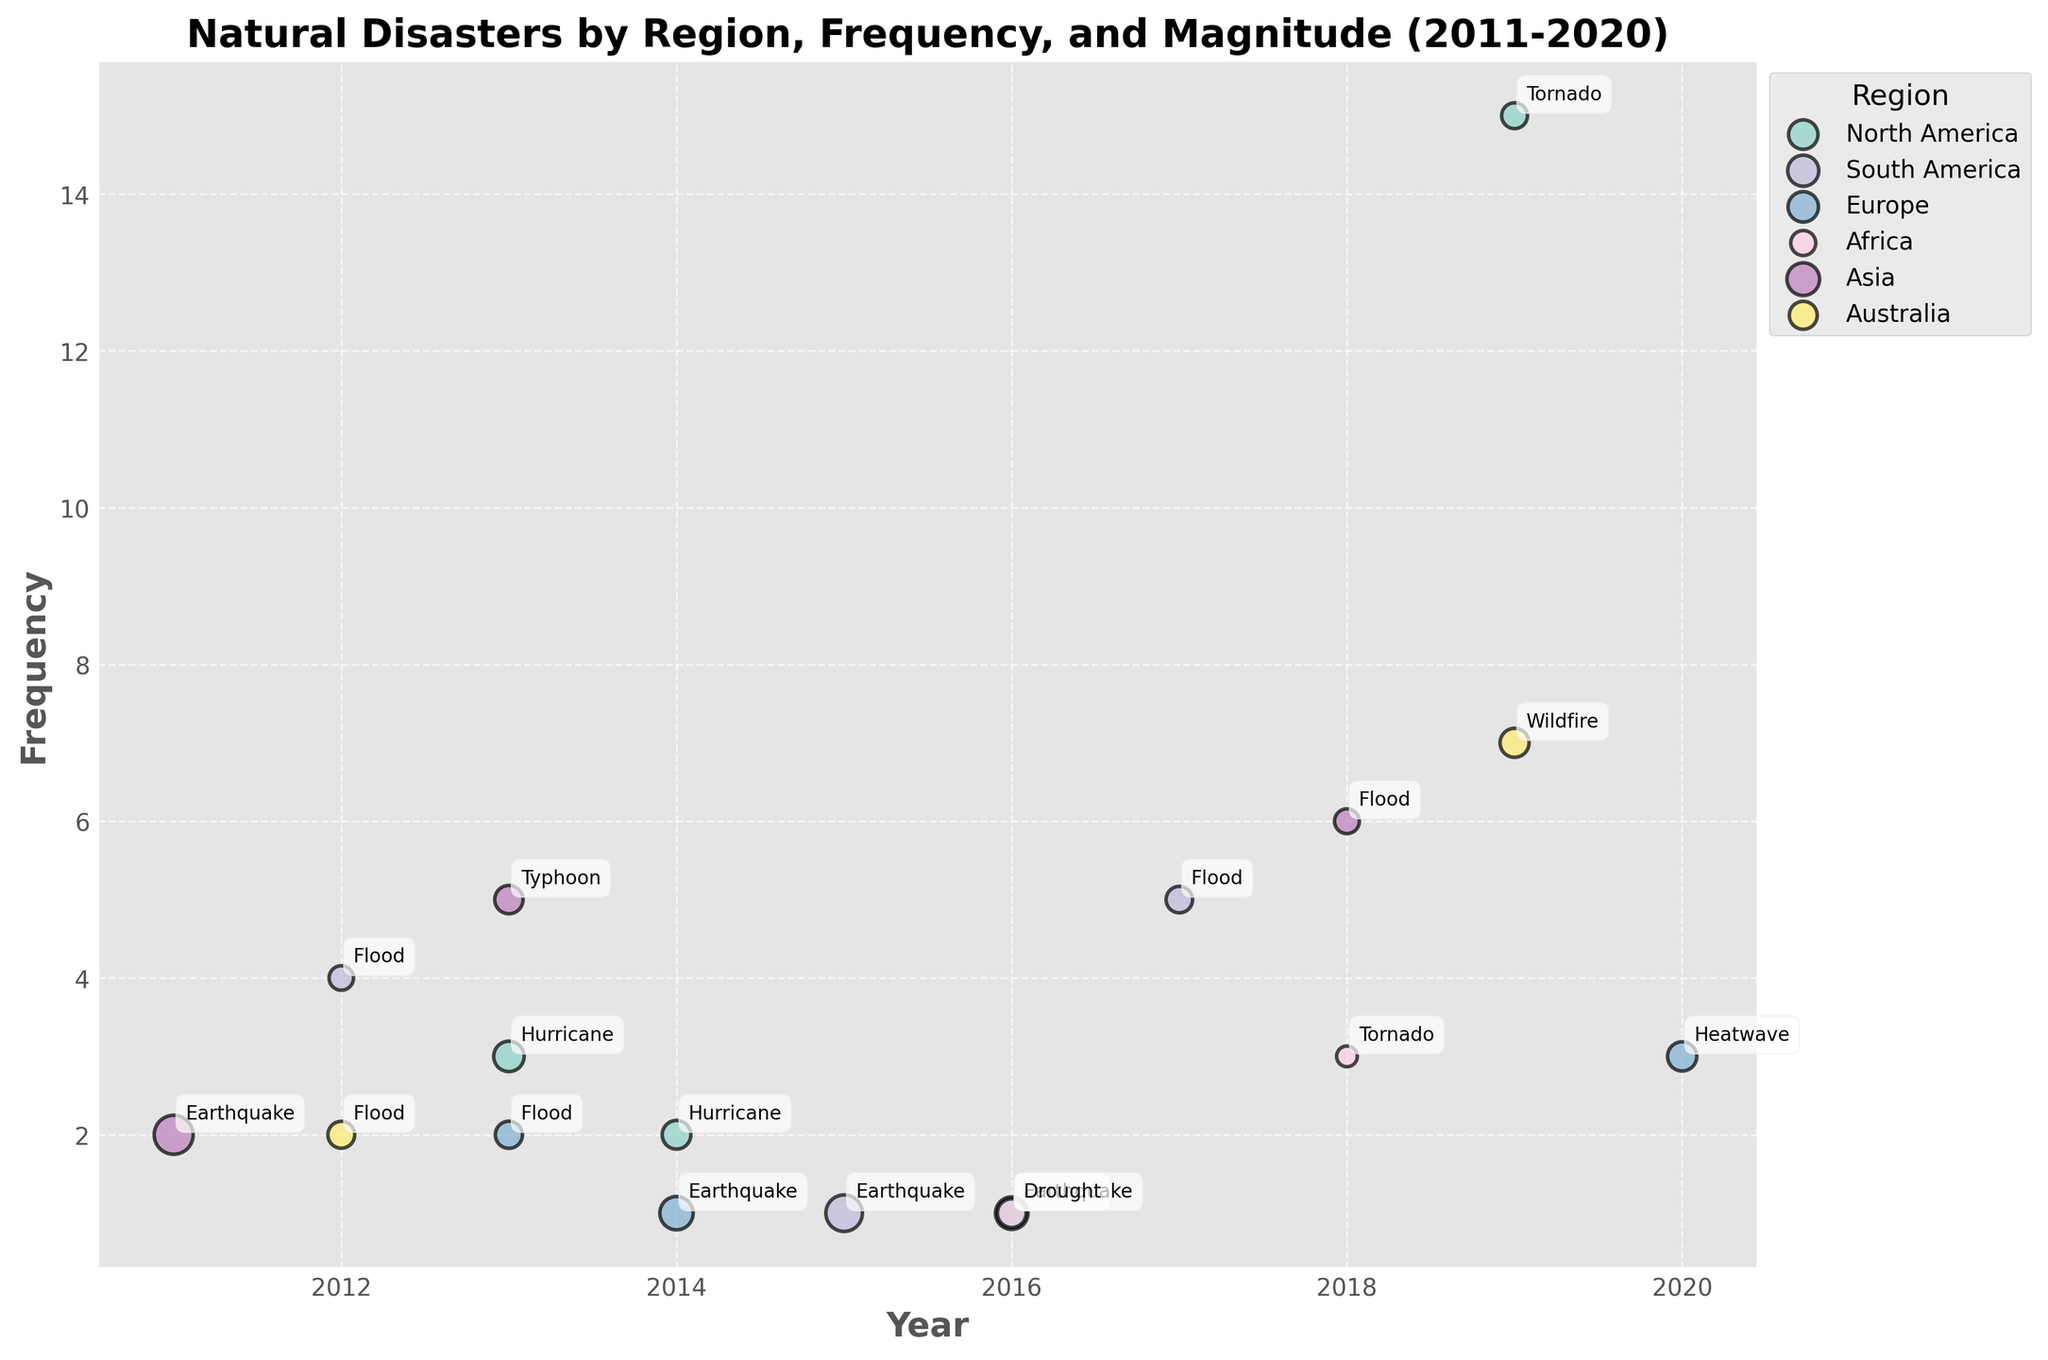What's the title of the chart? The title is typically displayed at the top of the chart. The title of this chart reads "Natural Disasters by Region, Frequency, and Magnitude (2011-2020)".
Answer: Natural Disasters by Region, Frequency, and Magnitude (2011-2020) Which year had the highest frequency of tornadoes? Check for the label 'Tornado' and identify the year with the highest y-value (Frequency). The highest frequency is in 2019 with a frequency of 15.
Answer: 2019 How many regions are represented in the plot? Look at the legend on the right-hand side of the plot, which lists all the different regions represented. There are 6 regions.
Answer: 6 What type of disaster had the highest magnitude in Asia? Look for entries labeled with the disaster type in Asia and compare their bubble sizes. The biggest bubble in Asia is for 'Earthquake' with a magnitude of 8.9 in 2011.
Answer: Earthquake Which region experienced wildfires, and in which year? Identify the label 'Wildfire' and then note its corresponding region and year. The only 'Wildfire' is in Australia in the year 2019.
Answer: Australia, 2019 Compare the frequencies of floods in South America between 2012 and 2017. Which year had more occurrences? Check the labels 'Flood' in South America for the years 2012 and 2017 and compare their y-values (Frequencies). In 2012, the frequency is 4, while in 2017, it is 5.
Answer: 2017 What is the average magnitude of earthquakes across all regions? Sum the magnitudes of all earthquakes and divide by the number of earthquake data points. Magnitudes are: 6.2, 6.5, 7.8, 8.9; their sum is 29.4, and there are 4 data points. The average is 29.4 / 4 = 7.35.
Answer: 7.35 What is the trend of hurricane occurrences in North America from 2013 to 2014? Look at the frequency of hurricanes in North America for the years 2013 and 2014, which are 3 and 2, respectively. The trend shows a decrease.
Answer: Decreasing Which disaster type in Europe had the highest frequency in 2020? Identify the year 2020 and the corresponding bubble labels in Europe. The label 'Heatwave' in 2020 has frequency 3.
Answer: Heatwave In which year did drought occur in Africa and what was its magnitude? Locate the label 'Drought' in Africa and note the year and magnitude. The 'Drought' occurred in 2016 with a magnitude of 4.8.
Answer: 2016, 4.8 